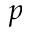Convert formula to latex. <formula><loc_0><loc_0><loc_500><loc_500>p</formula> 